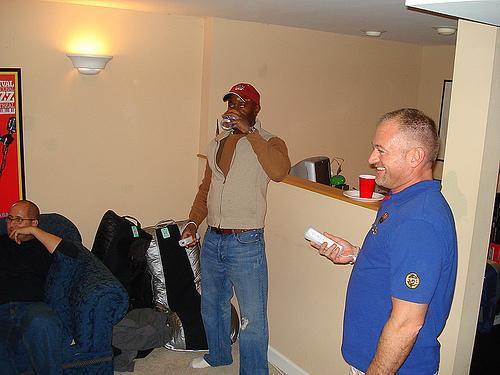How many men are in the photo?
Give a very brief answer. 3. 